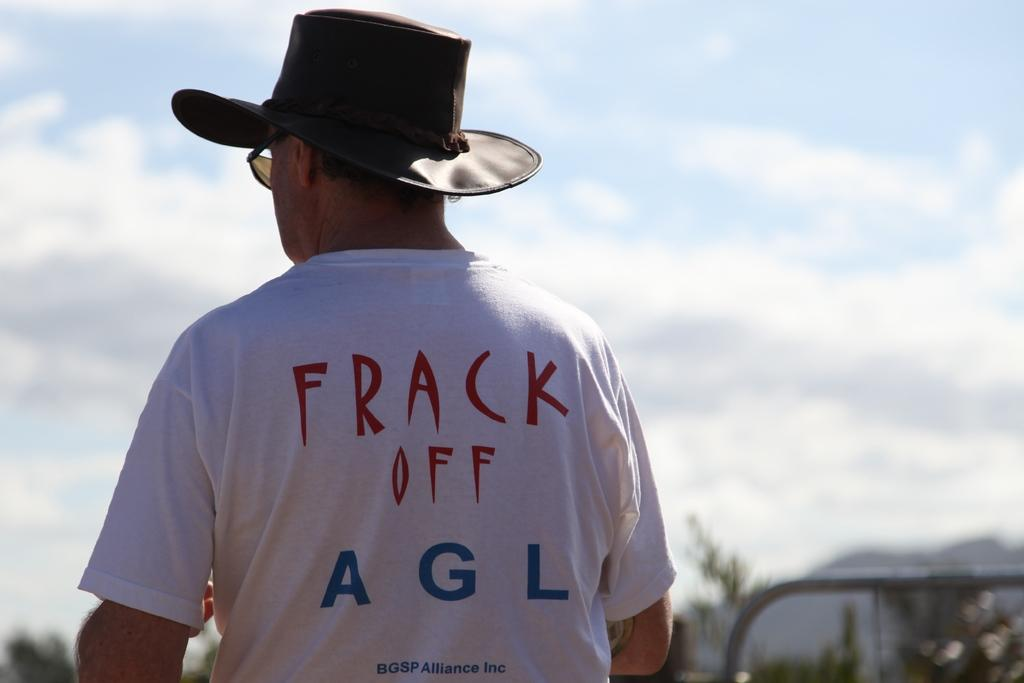Provide a one-sentence caption for the provided image. A man wearing a cowboy hat and a white tee with a saying "Frack off" is shown from the behind. 